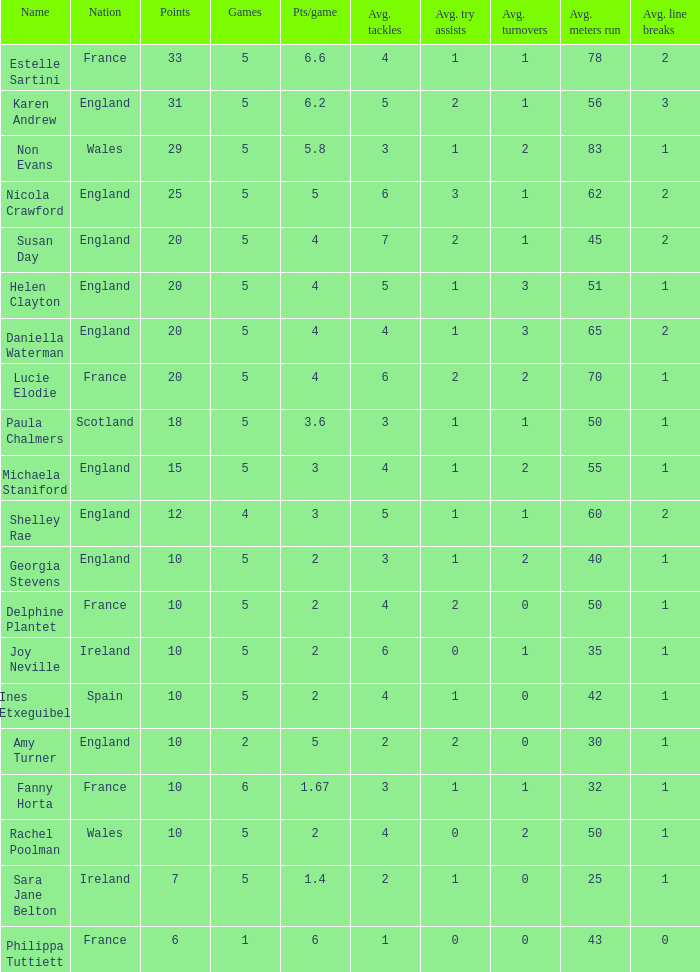Can you tell me the lowest Pts/game that has the Games larger than 6? None. 